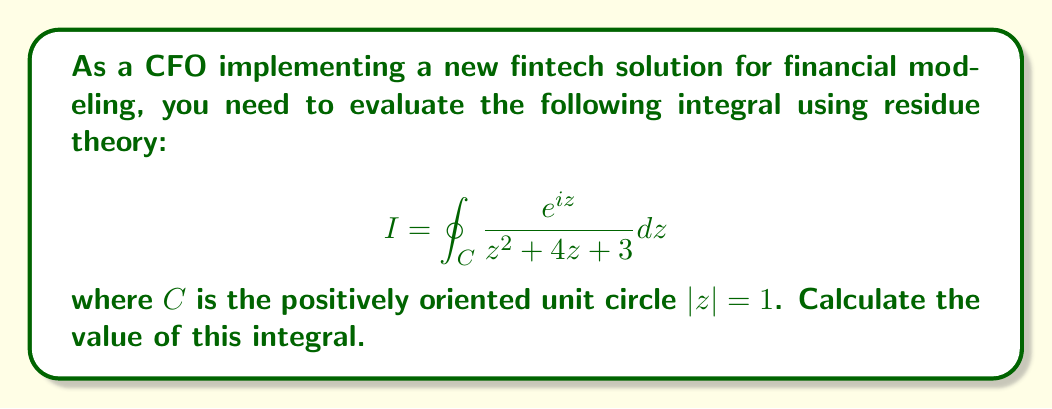Solve this math problem. To evaluate this integral using residue theory, we follow these steps:

1) First, we identify the poles of the integrand within the contour. The denominator can be factored as:

   $z^2 + 4z + 3 = (z+1)(z+3)$

   The poles are at $z=-1$ and $z=-3$. Only $z=-1$ lies within the unit circle.

2) We calculate the residue at $z=-1$:

   $\text{Res}(f,-1) = \lim_{z \to -1} (z+1) \frac{e^{iz}}{(z+1)(z+3)}$
                     $= \lim_{z \to -1} \frac{e^{iz}}{z+3}$
                     $= \frac{e^{-i}}{2}$

3) By the Residue Theorem, we have:

   $$ I = 2\pi i \sum \text{Residues inside } C $$

4) In this case, there's only one residue inside $C$, so:

   $$ I = 2\pi i \cdot \frac{e^{-i}}{2} = \pi i e^{-i} $$

5) To express this in a more standard form, we can use Euler's formula:

   $e^{-i} = \cos(-1) + i\sin(-1) = \cos(1) - i\sin(1)$

   Therefore,

   $$ I = \pi i (\cos(1) - i\sin(1)) = \pi (\sin(1) + i\cos(1)) $$

This final form gives us the real and imaginary parts of the integral.
Answer: $$ I = \pi (\sin(1) + i\cos(1)) $$ 